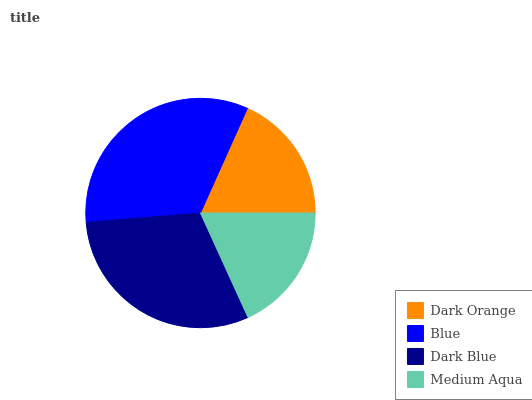Is Medium Aqua the minimum?
Answer yes or no. Yes. Is Blue the maximum?
Answer yes or no. Yes. Is Dark Blue the minimum?
Answer yes or no. No. Is Dark Blue the maximum?
Answer yes or no. No. Is Blue greater than Dark Blue?
Answer yes or no. Yes. Is Dark Blue less than Blue?
Answer yes or no. Yes. Is Dark Blue greater than Blue?
Answer yes or no. No. Is Blue less than Dark Blue?
Answer yes or no. No. Is Dark Blue the high median?
Answer yes or no. Yes. Is Dark Orange the low median?
Answer yes or no. Yes. Is Dark Orange the high median?
Answer yes or no. No. Is Blue the low median?
Answer yes or no. No. 